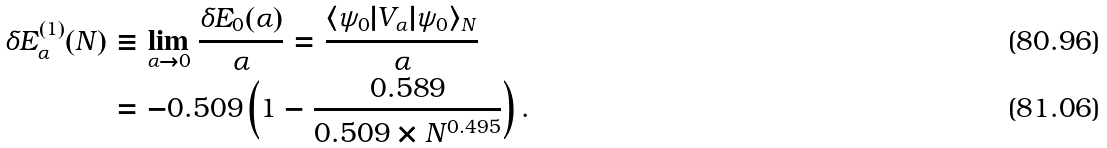Convert formula to latex. <formula><loc_0><loc_0><loc_500><loc_500>\delta E _ { \alpha } ^ { ( 1 ) } ( N ) & \equiv \lim _ { \alpha \to 0 } \frac { \delta E _ { 0 } ( \alpha ) } { \alpha } = \frac { \langle \psi _ { 0 } | V _ { \alpha } | \psi _ { 0 } \rangle _ { N } } { \alpha } \\ & = - 0 . 5 0 9 \left ( 1 - \frac { 0 . 5 8 9 } { 0 . 5 0 9 \times N ^ { 0 . 4 9 5 } } \right ) .</formula> 